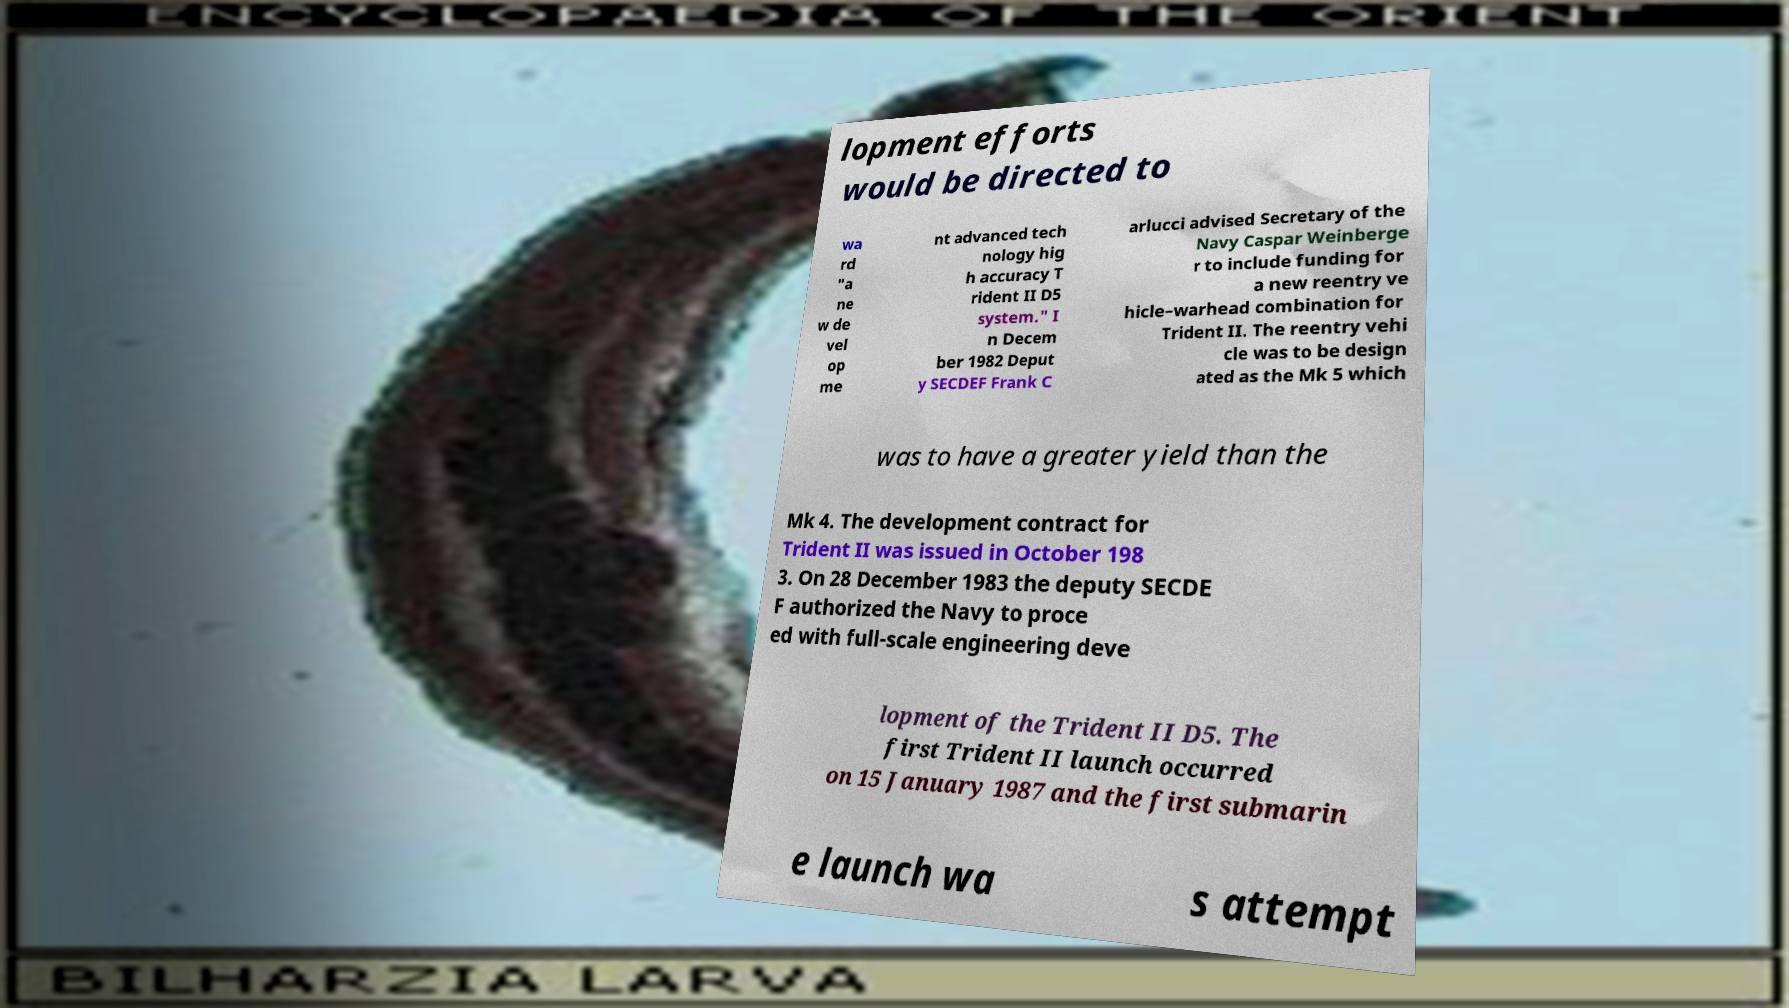I need the written content from this picture converted into text. Can you do that? lopment efforts would be directed to wa rd "a ne w de vel op me nt advanced tech nology hig h accuracy T rident II D5 system." I n Decem ber 1982 Deput y SECDEF Frank C arlucci advised Secretary of the Navy Caspar Weinberge r to include funding for a new reentry ve hicle–warhead combination for Trident II. The reentry vehi cle was to be design ated as the Mk 5 which was to have a greater yield than the Mk 4. The development contract for Trident II was issued in October 198 3. On 28 December 1983 the deputy SECDE F authorized the Navy to proce ed with full-scale engineering deve lopment of the Trident II D5. The first Trident II launch occurred on 15 January 1987 and the first submarin e launch wa s attempt 